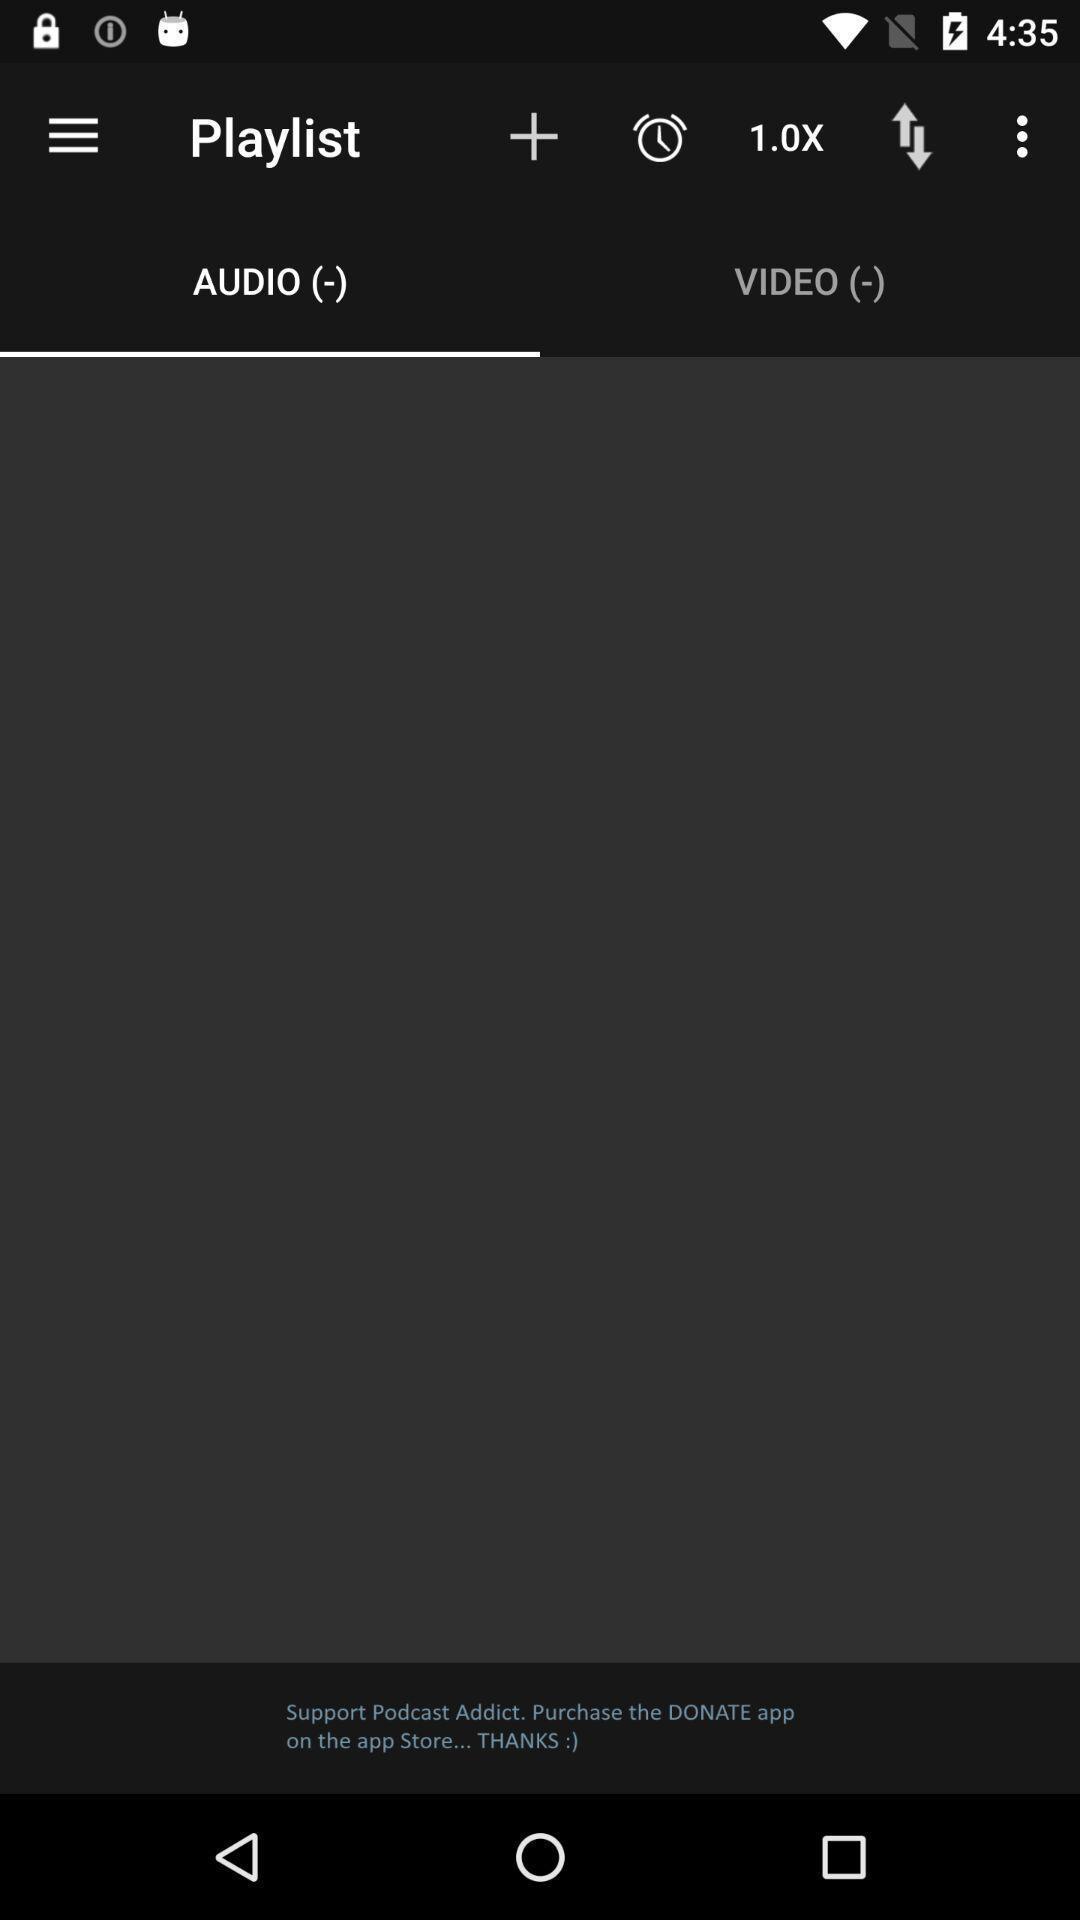Explain the elements present in this screenshot. Screen shows audio playlist page in podcast application. 